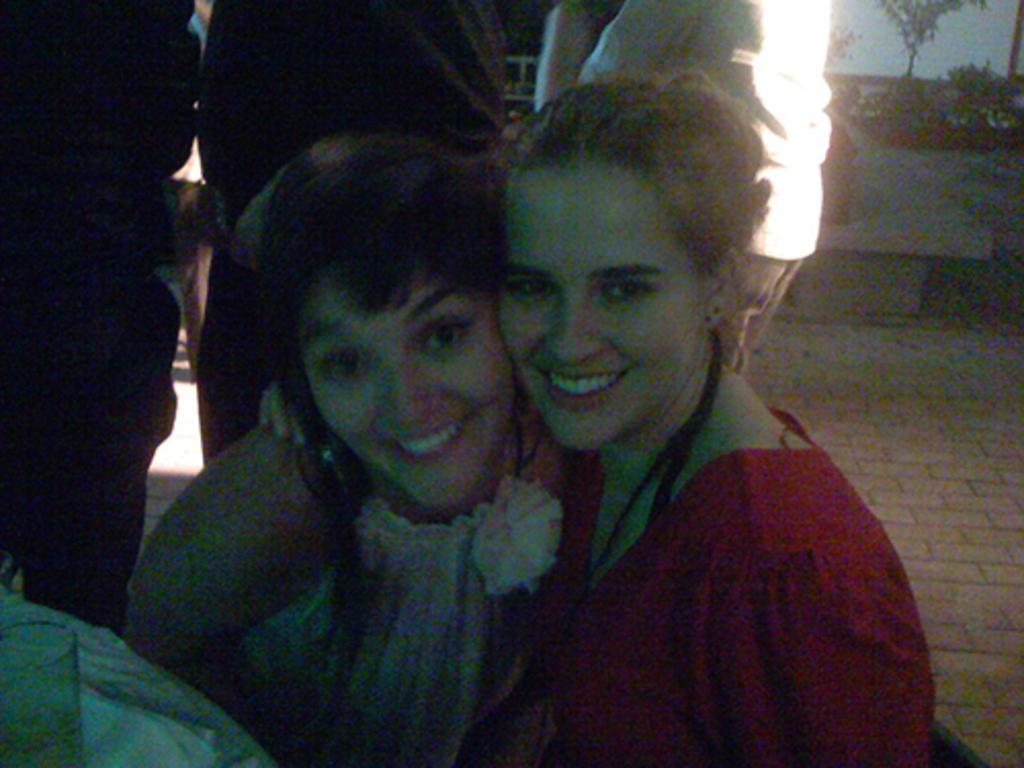Can you describe this image briefly? In this image I can see two women are smiling and giving pose for the picture. In the background, I can see few people are standing. On the right side there is a bench and trees. 